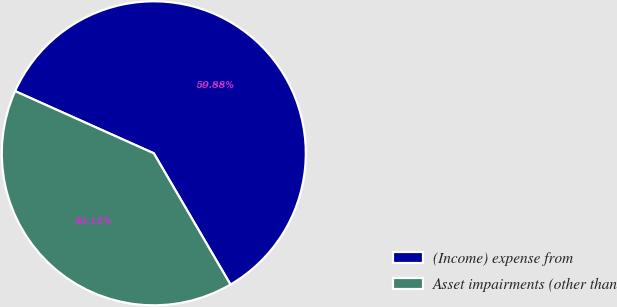<chart> <loc_0><loc_0><loc_500><loc_500><pie_chart><fcel>(Income) expense from<fcel>Asset impairments (other than<nl><fcel>59.88%<fcel>40.12%<nl></chart> 